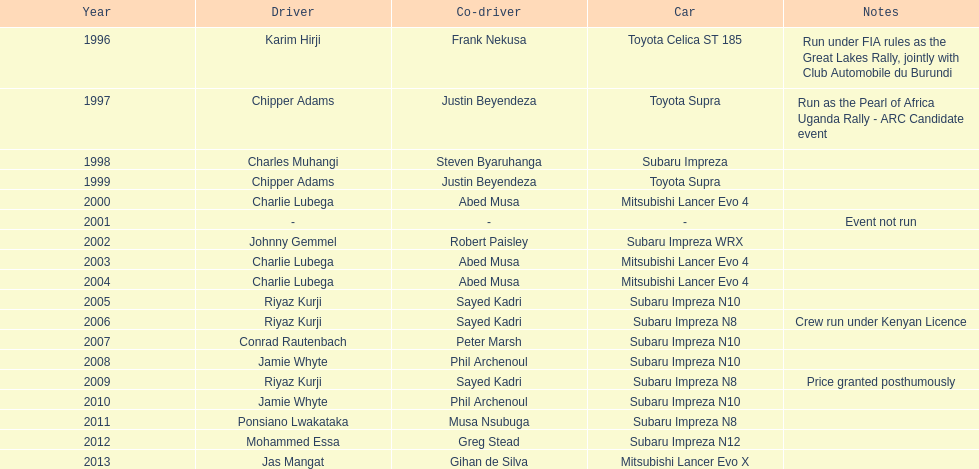How many drivers are racing with a co-driver from a different country? 1. 